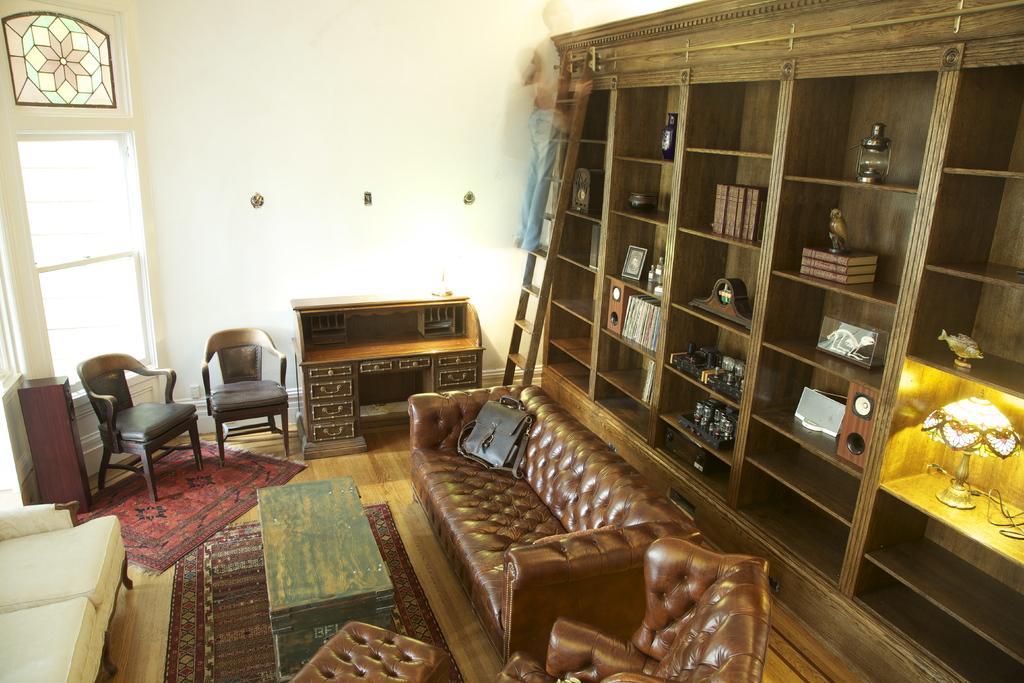Please provide a concise description of this image. In this picture we can see a room with sofa bag on it, chairs, table, ladder, racks with books, lamps, photo frames in it, wall, window. 